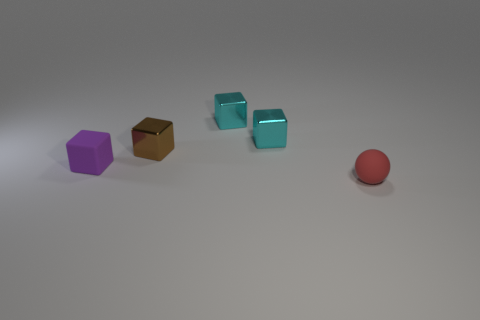What is the shape of the matte object behind the tiny red object that is in front of the tiny cube on the left side of the tiny brown metal block?
Offer a terse response. Cube. There is a rubber object that is to the left of the tiny matte object right of the small purple matte thing; what shape is it?
Provide a succinct answer. Cube. What number of gray objects are metallic cubes or big shiny cubes?
Your answer should be compact. 0. Are there any small rubber balls of the same color as the matte cube?
Your answer should be very brief. No. How many blocks are tiny red matte objects or small shiny objects?
Your answer should be very brief. 3. Is the number of red objects greater than the number of large blue cubes?
Provide a succinct answer. Yes. What number of other rubber things are the same size as the purple matte thing?
Your answer should be compact. 1. How many things are either small rubber objects that are to the left of the tiny ball or small cyan rubber blocks?
Provide a short and direct response. 1. Is the number of small cubes less than the number of small things?
Give a very brief answer. Yes. What is the shape of the thing that is made of the same material as the purple cube?
Give a very brief answer. Sphere. 